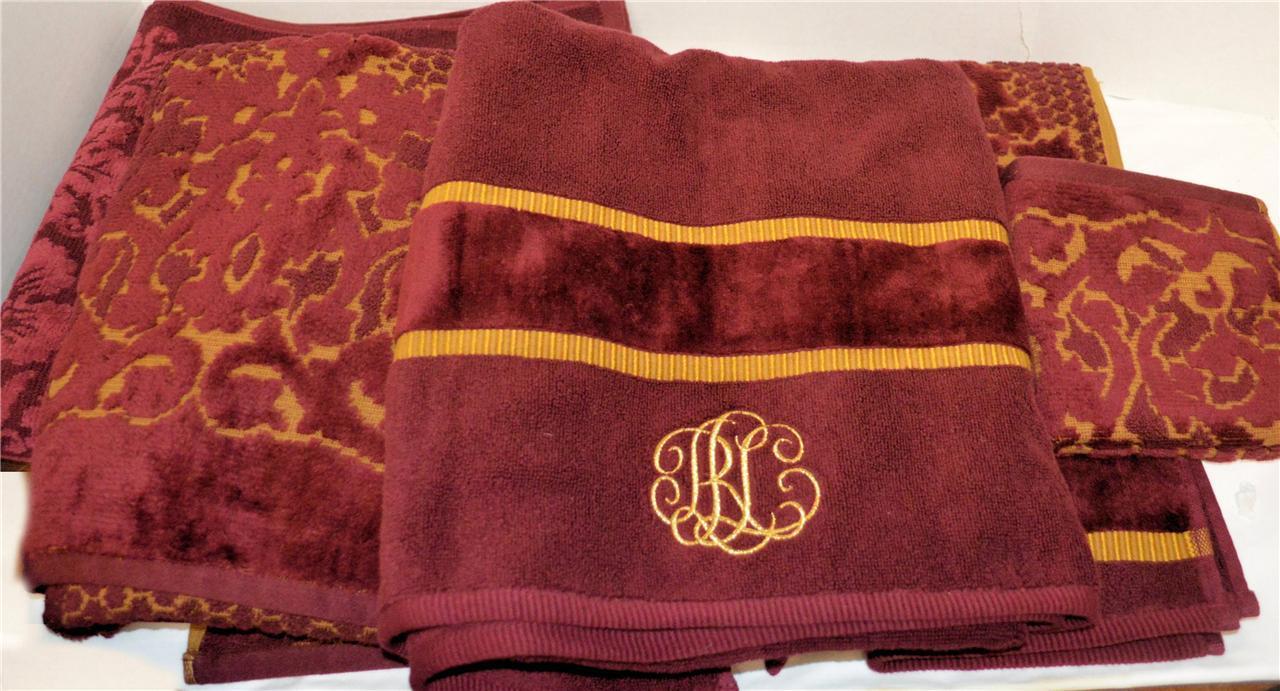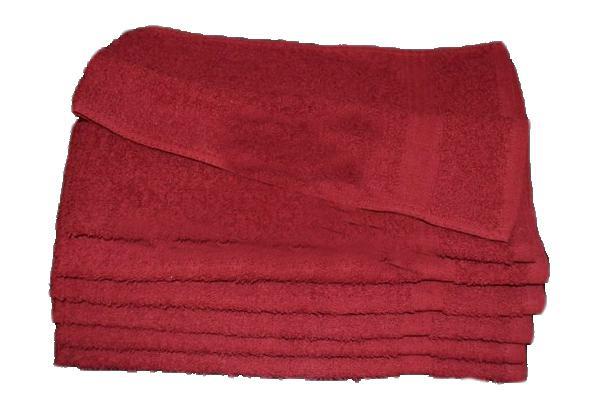The first image is the image on the left, the second image is the image on the right. Considering the images on both sides, is "IN at least one image there is a tower of three red towels." valid? Answer yes or no. No. The first image is the image on the left, the second image is the image on the right. Evaluate the accuracy of this statement regarding the images: "Seven or fewer towels are visible.". Is it true? Answer yes or no. No. 